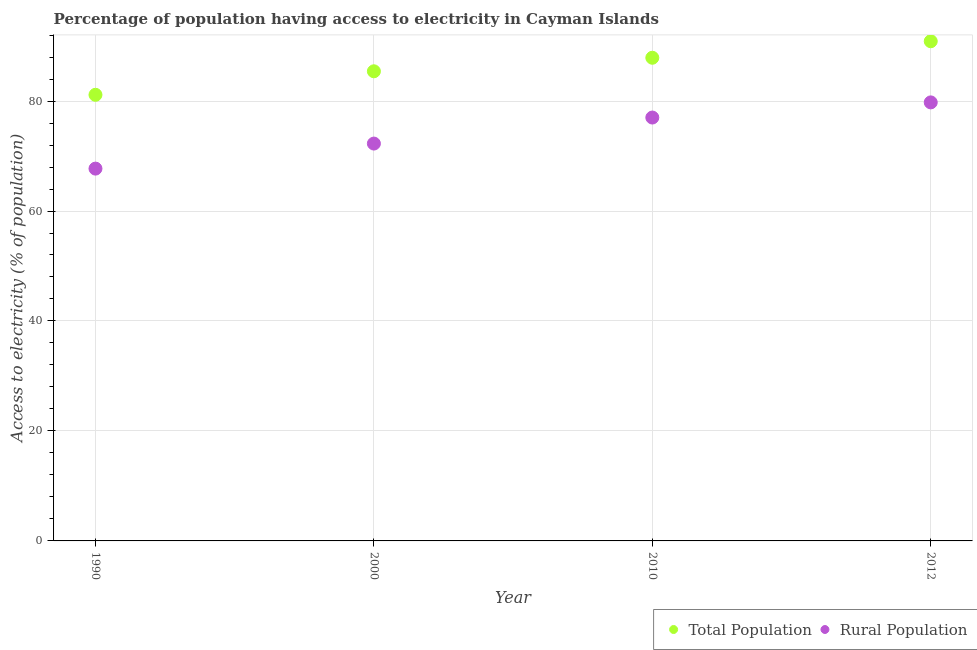How many different coloured dotlines are there?
Ensure brevity in your answer.  2. Is the number of dotlines equal to the number of legend labels?
Your answer should be compact. Yes. What is the percentage of population having access to electricity in 1990?
Your response must be concise. 81.14. Across all years, what is the maximum percentage of population having access to electricity?
Give a very brief answer. 90.88. Across all years, what is the minimum percentage of rural population having access to electricity?
Offer a very short reply. 67.71. In which year was the percentage of population having access to electricity maximum?
Keep it short and to the point. 2012. In which year was the percentage of population having access to electricity minimum?
Give a very brief answer. 1990. What is the total percentage of rural population having access to electricity in the graph?
Keep it short and to the point. 296.73. What is the difference between the percentage of rural population having access to electricity in 1990 and that in 2010?
Give a very brief answer. -9.29. What is the difference between the percentage of rural population having access to electricity in 2010 and the percentage of population having access to electricity in 1990?
Ensure brevity in your answer.  -4.14. What is the average percentage of population having access to electricity per year?
Make the answer very short. 86.32. In the year 2010, what is the difference between the percentage of rural population having access to electricity and percentage of population having access to electricity?
Ensure brevity in your answer.  -10.87. In how many years, is the percentage of rural population having access to electricity greater than 68 %?
Your answer should be very brief. 3. What is the ratio of the percentage of population having access to electricity in 2010 to that in 2012?
Give a very brief answer. 0.97. What is the difference between the highest and the second highest percentage of population having access to electricity?
Your response must be concise. 3. What is the difference between the highest and the lowest percentage of population having access to electricity?
Offer a terse response. 9.74. Is the percentage of rural population having access to electricity strictly less than the percentage of population having access to electricity over the years?
Your answer should be very brief. Yes. How many dotlines are there?
Keep it short and to the point. 2. How many years are there in the graph?
Provide a succinct answer. 4. What is the difference between two consecutive major ticks on the Y-axis?
Your answer should be compact. 20. Are the values on the major ticks of Y-axis written in scientific E-notation?
Offer a very short reply. No. Does the graph contain grids?
Provide a succinct answer. Yes. How many legend labels are there?
Provide a succinct answer. 2. What is the title of the graph?
Your answer should be very brief. Percentage of population having access to electricity in Cayman Islands. Does "By country of origin" appear as one of the legend labels in the graph?
Provide a short and direct response. No. What is the label or title of the Y-axis?
Your answer should be compact. Access to electricity (% of population). What is the Access to electricity (% of population) of Total Population in 1990?
Offer a terse response. 81.14. What is the Access to electricity (% of population) in Rural Population in 1990?
Your answer should be very brief. 67.71. What is the Access to electricity (% of population) in Total Population in 2000?
Make the answer very short. 85.41. What is the Access to electricity (% of population) in Rural Population in 2000?
Offer a very short reply. 72.27. What is the Access to electricity (% of population) in Total Population in 2010?
Make the answer very short. 87.87. What is the Access to electricity (% of population) in Total Population in 2012?
Provide a succinct answer. 90.88. What is the Access to electricity (% of population) in Rural Population in 2012?
Make the answer very short. 79.75. Across all years, what is the maximum Access to electricity (% of population) in Total Population?
Ensure brevity in your answer.  90.88. Across all years, what is the maximum Access to electricity (% of population) of Rural Population?
Provide a short and direct response. 79.75. Across all years, what is the minimum Access to electricity (% of population) in Total Population?
Keep it short and to the point. 81.14. Across all years, what is the minimum Access to electricity (% of population) in Rural Population?
Your answer should be very brief. 67.71. What is the total Access to electricity (% of population) in Total Population in the graph?
Ensure brevity in your answer.  345.3. What is the total Access to electricity (% of population) of Rural Population in the graph?
Give a very brief answer. 296.73. What is the difference between the Access to electricity (% of population) in Total Population in 1990 and that in 2000?
Your answer should be very brief. -4.28. What is the difference between the Access to electricity (% of population) of Rural Population in 1990 and that in 2000?
Your response must be concise. -4.55. What is the difference between the Access to electricity (% of population) of Total Population in 1990 and that in 2010?
Keep it short and to the point. -6.74. What is the difference between the Access to electricity (% of population) of Rural Population in 1990 and that in 2010?
Keep it short and to the point. -9.29. What is the difference between the Access to electricity (% of population) of Total Population in 1990 and that in 2012?
Keep it short and to the point. -9.74. What is the difference between the Access to electricity (% of population) in Rural Population in 1990 and that in 2012?
Your response must be concise. -12.04. What is the difference between the Access to electricity (% of population) of Total Population in 2000 and that in 2010?
Make the answer very short. -2.46. What is the difference between the Access to electricity (% of population) of Rural Population in 2000 and that in 2010?
Provide a succinct answer. -4.74. What is the difference between the Access to electricity (% of population) of Total Population in 2000 and that in 2012?
Make the answer very short. -5.46. What is the difference between the Access to electricity (% of population) of Rural Population in 2000 and that in 2012?
Offer a terse response. -7.49. What is the difference between the Access to electricity (% of population) in Total Population in 2010 and that in 2012?
Your answer should be compact. -3. What is the difference between the Access to electricity (% of population) of Rural Population in 2010 and that in 2012?
Give a very brief answer. -2.75. What is the difference between the Access to electricity (% of population) of Total Population in 1990 and the Access to electricity (% of population) of Rural Population in 2000?
Your response must be concise. 8.87. What is the difference between the Access to electricity (% of population) in Total Population in 1990 and the Access to electricity (% of population) in Rural Population in 2010?
Provide a succinct answer. 4.14. What is the difference between the Access to electricity (% of population) of Total Population in 1990 and the Access to electricity (% of population) of Rural Population in 2012?
Provide a succinct answer. 1.38. What is the difference between the Access to electricity (% of population) of Total Population in 2000 and the Access to electricity (% of population) of Rural Population in 2010?
Keep it short and to the point. 8.41. What is the difference between the Access to electricity (% of population) of Total Population in 2000 and the Access to electricity (% of population) of Rural Population in 2012?
Your response must be concise. 5.66. What is the difference between the Access to electricity (% of population) in Total Population in 2010 and the Access to electricity (% of population) in Rural Population in 2012?
Your response must be concise. 8.12. What is the average Access to electricity (% of population) of Total Population per year?
Provide a short and direct response. 86.32. What is the average Access to electricity (% of population) in Rural Population per year?
Provide a short and direct response. 74.18. In the year 1990, what is the difference between the Access to electricity (% of population) of Total Population and Access to electricity (% of population) of Rural Population?
Give a very brief answer. 13.42. In the year 2000, what is the difference between the Access to electricity (% of population) of Total Population and Access to electricity (% of population) of Rural Population?
Make the answer very short. 13.15. In the year 2010, what is the difference between the Access to electricity (% of population) of Total Population and Access to electricity (% of population) of Rural Population?
Your answer should be compact. 10.87. In the year 2012, what is the difference between the Access to electricity (% of population) of Total Population and Access to electricity (% of population) of Rural Population?
Keep it short and to the point. 11.12. What is the ratio of the Access to electricity (% of population) of Total Population in 1990 to that in 2000?
Ensure brevity in your answer.  0.95. What is the ratio of the Access to electricity (% of population) of Rural Population in 1990 to that in 2000?
Your response must be concise. 0.94. What is the ratio of the Access to electricity (% of population) of Total Population in 1990 to that in 2010?
Keep it short and to the point. 0.92. What is the ratio of the Access to electricity (% of population) of Rural Population in 1990 to that in 2010?
Your answer should be compact. 0.88. What is the ratio of the Access to electricity (% of population) of Total Population in 1990 to that in 2012?
Your answer should be compact. 0.89. What is the ratio of the Access to electricity (% of population) in Rural Population in 1990 to that in 2012?
Make the answer very short. 0.85. What is the ratio of the Access to electricity (% of population) of Total Population in 2000 to that in 2010?
Your answer should be very brief. 0.97. What is the ratio of the Access to electricity (% of population) in Rural Population in 2000 to that in 2010?
Keep it short and to the point. 0.94. What is the ratio of the Access to electricity (% of population) in Total Population in 2000 to that in 2012?
Your answer should be compact. 0.94. What is the ratio of the Access to electricity (% of population) of Rural Population in 2000 to that in 2012?
Provide a succinct answer. 0.91. What is the ratio of the Access to electricity (% of population) of Total Population in 2010 to that in 2012?
Provide a succinct answer. 0.97. What is the ratio of the Access to electricity (% of population) in Rural Population in 2010 to that in 2012?
Give a very brief answer. 0.97. What is the difference between the highest and the second highest Access to electricity (% of population) in Total Population?
Make the answer very short. 3. What is the difference between the highest and the second highest Access to electricity (% of population) of Rural Population?
Your response must be concise. 2.75. What is the difference between the highest and the lowest Access to electricity (% of population) in Total Population?
Offer a terse response. 9.74. What is the difference between the highest and the lowest Access to electricity (% of population) of Rural Population?
Offer a terse response. 12.04. 